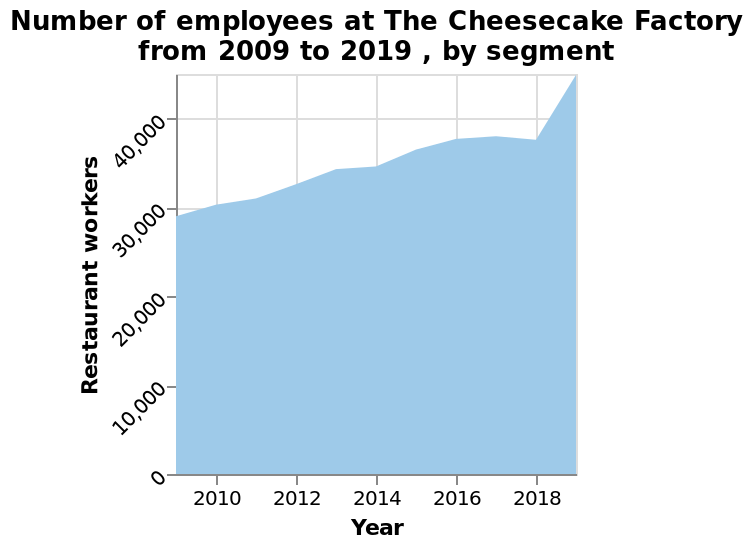<image>
What has been the trend in the number of restaurant workers from 2010 to 2018?  The number of restaurant workers has steadily increased from 2010 to 2018. What does the y-axis represent in the area diagram?  The y-axis represents the number of Restaurant workers at The Cheesecake Factory from 2009 to 2019. What is the range of the x-axis in the graph?  The x-axis ranges from 2010 to 2018, representing the years. 